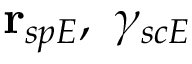Convert formula to latex. <formula><loc_0><loc_0><loc_500><loc_500>r _ { s p E } , \ \gamma _ { s c E }</formula> 